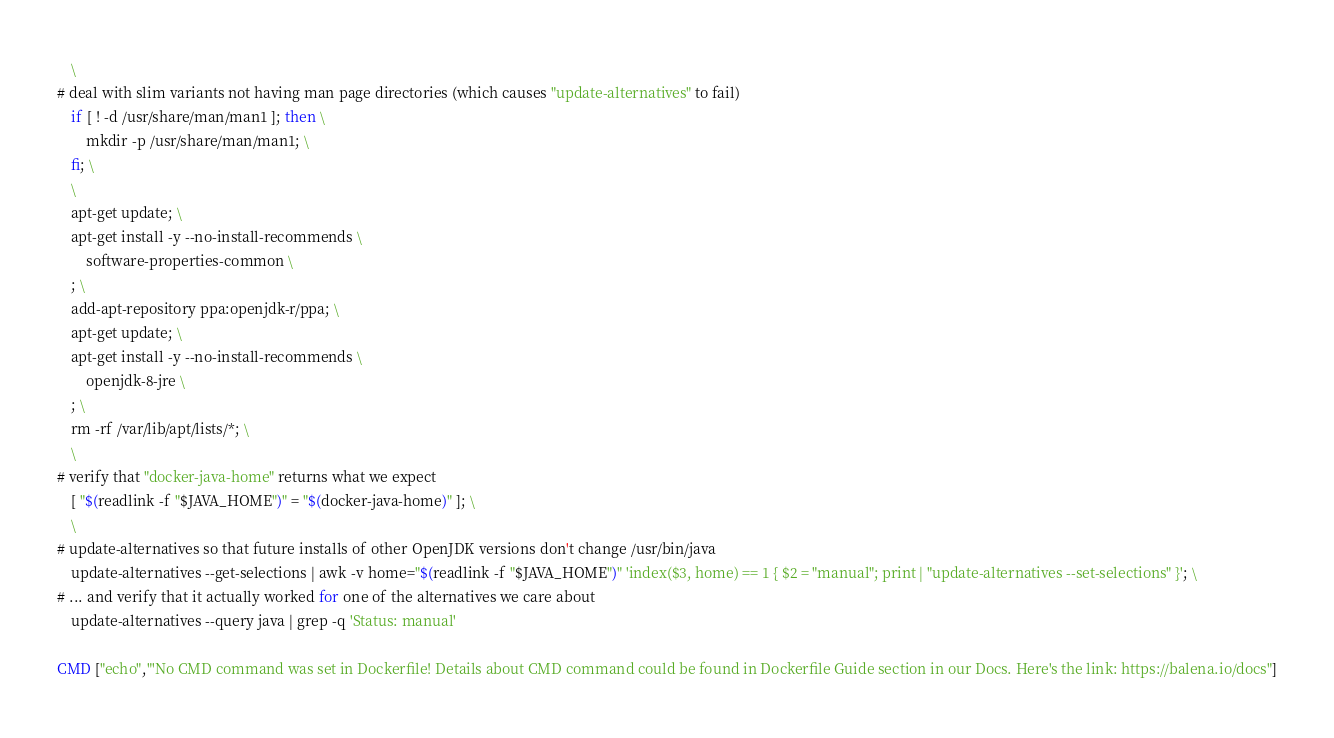Convert code to text. <code><loc_0><loc_0><loc_500><loc_500><_Dockerfile_>	\
# deal with slim variants not having man page directories (which causes "update-alternatives" to fail)
	if [ ! -d /usr/share/man/man1 ]; then \
		mkdir -p /usr/share/man/man1; \
	fi; \
	\
	apt-get update; \
	apt-get install -y --no-install-recommends \
		software-properties-common \
	; \
	add-apt-repository ppa:openjdk-r/ppa; \
	apt-get update; \
	apt-get install -y --no-install-recommends \
		openjdk-8-jre \
	; \
	rm -rf /var/lib/apt/lists/*; \
	\
# verify that "docker-java-home" returns what we expect
	[ "$(readlink -f "$JAVA_HOME")" = "$(docker-java-home)" ]; \
	\
# update-alternatives so that future installs of other OpenJDK versions don't change /usr/bin/java
	update-alternatives --get-selections | awk -v home="$(readlink -f "$JAVA_HOME")" 'index($3, home) == 1 { $2 = "manual"; print | "update-alternatives --set-selections" }'; \
# ... and verify that it actually worked for one of the alternatives we care about
	update-alternatives --query java | grep -q 'Status: manual'

CMD ["echo","'No CMD command was set in Dockerfile! Details about CMD command could be found in Dockerfile Guide section in our Docs. Here's the link: https://balena.io/docs"]
</code> 